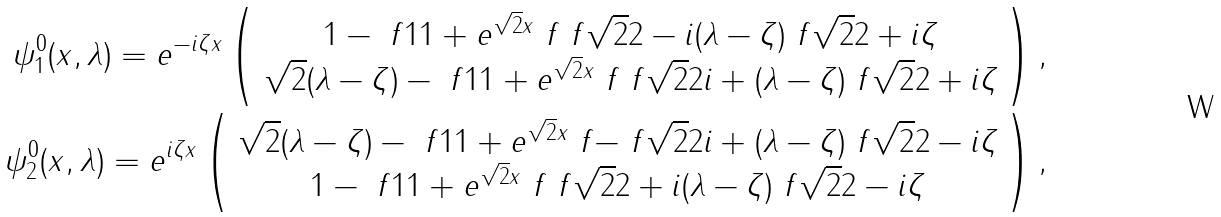<formula> <loc_0><loc_0><loc_500><loc_500>\psi _ { 1 } ^ { 0 } ( x , \lambda ) = e ^ { - i \zeta x } \left ( \begin{array} { c } 1 - \ f 1 { 1 + e ^ { \sqrt { 2 } x } } \ f { \ f { \sqrt { 2 } } 2 - i ( \lambda - \zeta ) } { \ f { \sqrt { 2 } } 2 + i \zeta } \\ \sqrt { 2 } ( \lambda - \zeta ) - \ f 1 { 1 + e ^ { \sqrt { 2 } x } } \ f { \ f { \sqrt { 2 } } 2 i + ( \lambda - \zeta ) } { \ f { \sqrt { 2 } } 2 + i \zeta } \end{array} \right ) , \\ \psi _ { 2 } ^ { 0 } ( x , \lambda ) = e ^ { i \zeta x } \left ( \begin{array} { c } \sqrt { 2 } ( \lambda - \zeta ) - \ f 1 { 1 + e ^ { \sqrt { 2 } x } } \ f { - \ f { \sqrt { 2 } } 2 i + ( \lambda - \zeta ) } { \ f { \sqrt { 2 } } 2 - i \zeta } \\ 1 - \ f 1 { 1 + e ^ { \sqrt { 2 } x } } \ f { \ f { \sqrt { 2 } } 2 + i ( \lambda - \zeta ) } { \ f { \sqrt { 2 } } 2 - i \zeta } \end{array} \right ) ,</formula> 